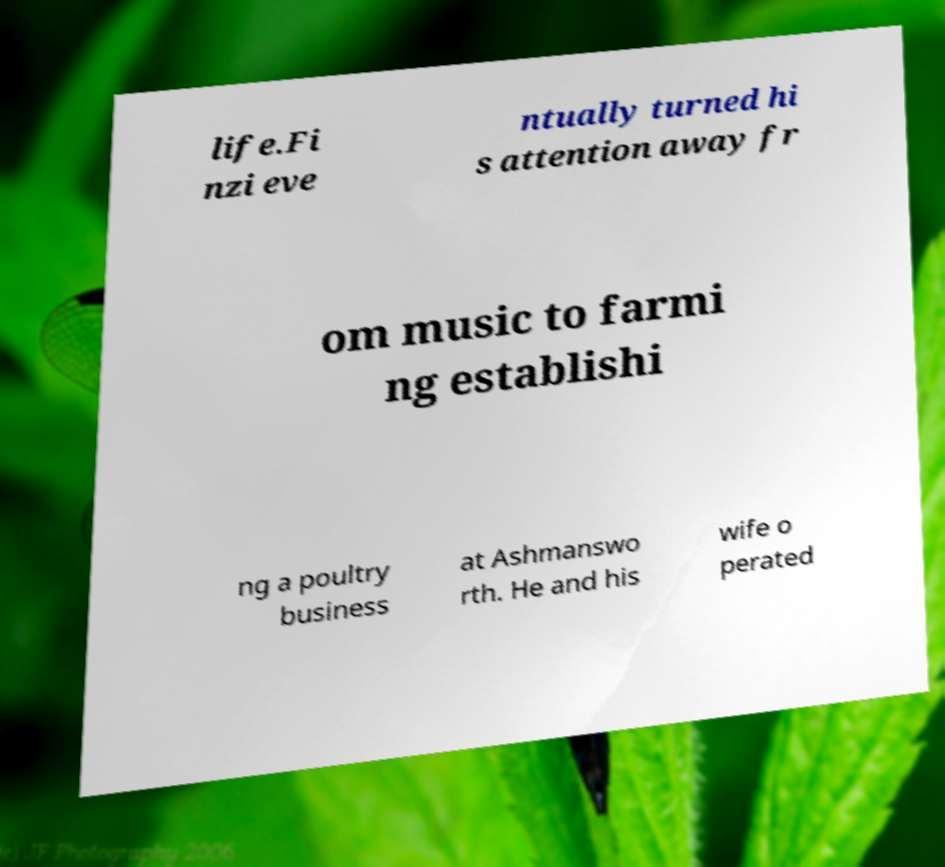Could you assist in decoding the text presented in this image and type it out clearly? life.Fi nzi eve ntually turned hi s attention away fr om music to farmi ng establishi ng a poultry business at Ashmanswo rth. He and his wife o perated 